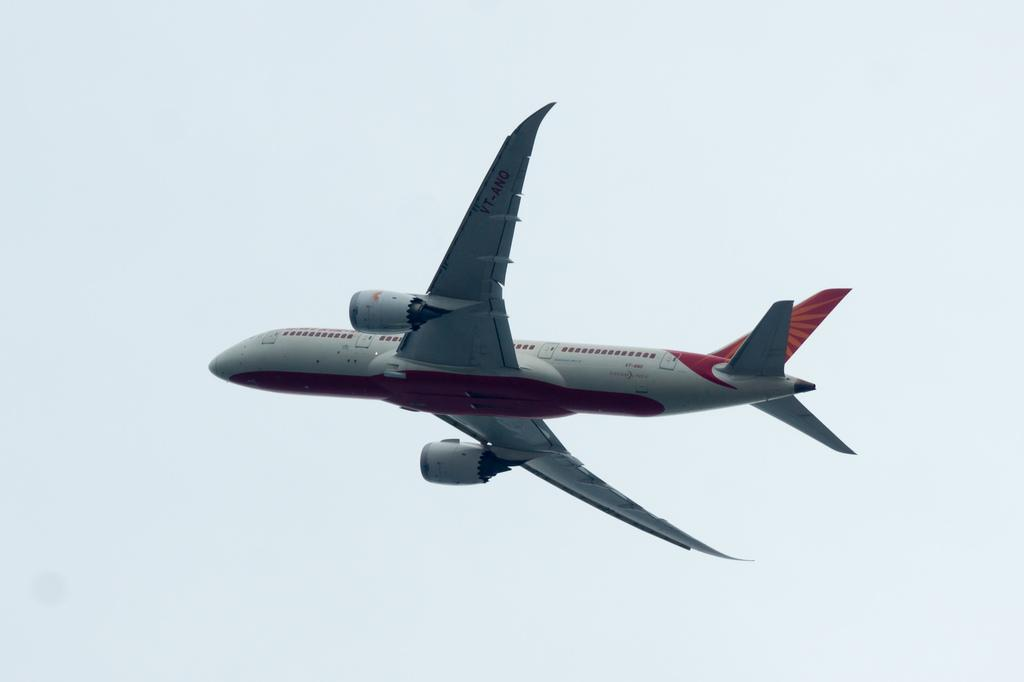What is the main subject of the image? The main subject of the image is an airplane. What is the airplane doing in the image? The airplane is flying in the air. What can be seen in the background of the image? There are clouds in the sky in the background of the image. What type of field is visible in the image? There is no field present in the image; it features an airplane flying in the sky with clouds in the background. 